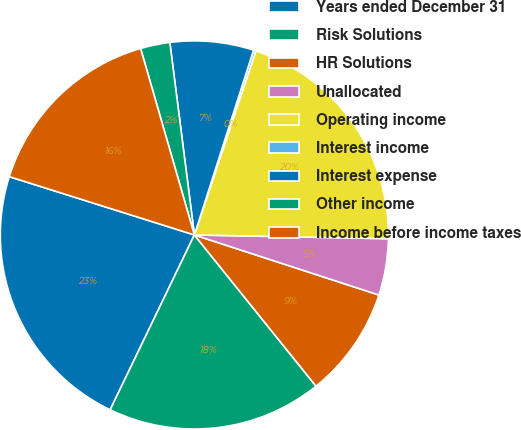Convert chart to OTSL. <chart><loc_0><loc_0><loc_500><loc_500><pie_chart><fcel>Years ended December 31<fcel>Risk Solutions<fcel>HR Solutions<fcel>Unallocated<fcel>Operating income<fcel>Interest income<fcel>Interest expense<fcel>Other income<fcel>Income before income taxes<nl><fcel>22.71%<fcel>17.92%<fcel>9.21%<fcel>4.7%<fcel>20.17%<fcel>0.2%<fcel>6.95%<fcel>2.45%<fcel>15.67%<nl></chart> 